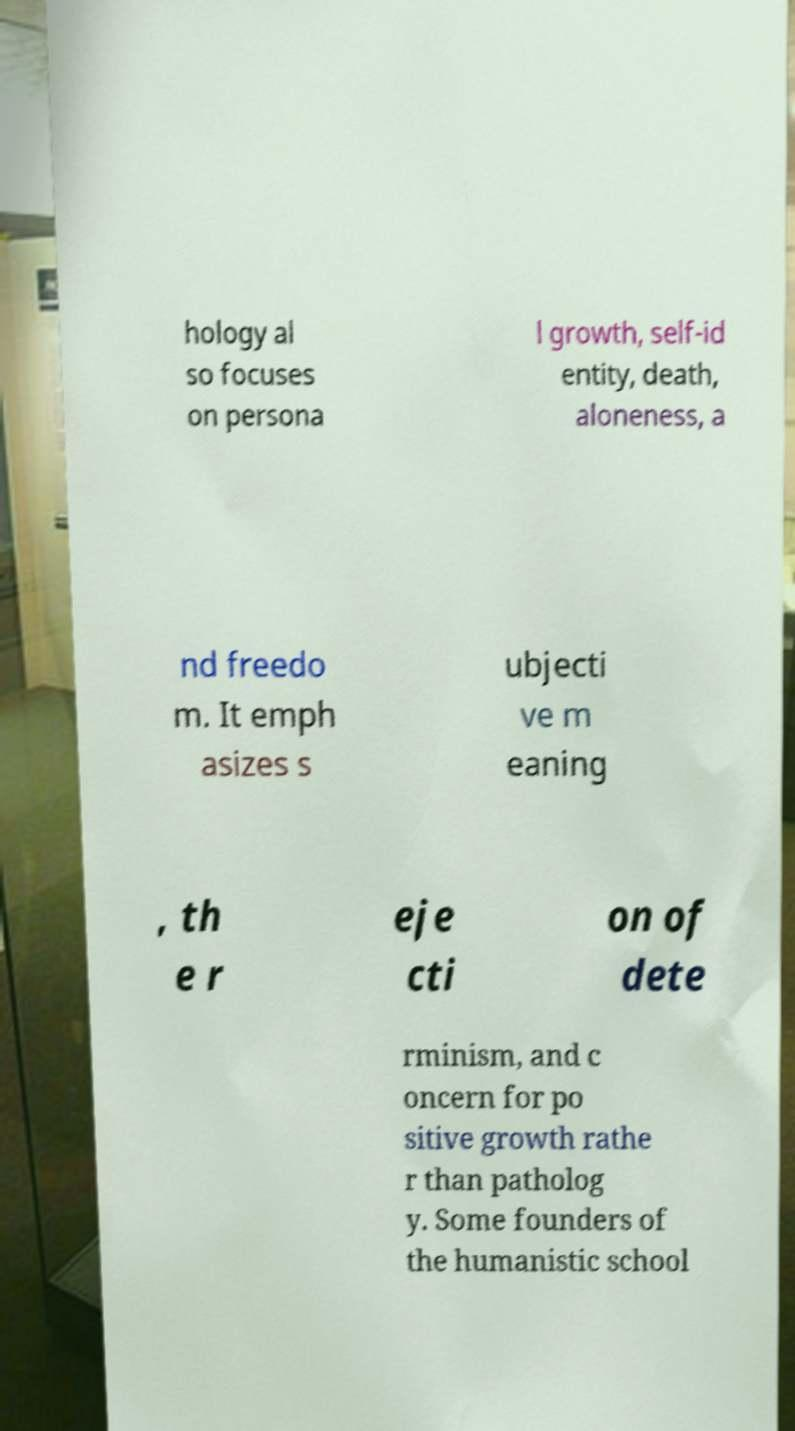Please identify and transcribe the text found in this image. hology al so focuses on persona l growth, self-id entity, death, aloneness, a nd freedo m. It emph asizes s ubjecti ve m eaning , th e r eje cti on of dete rminism, and c oncern for po sitive growth rathe r than patholog y. Some founders of the humanistic school 